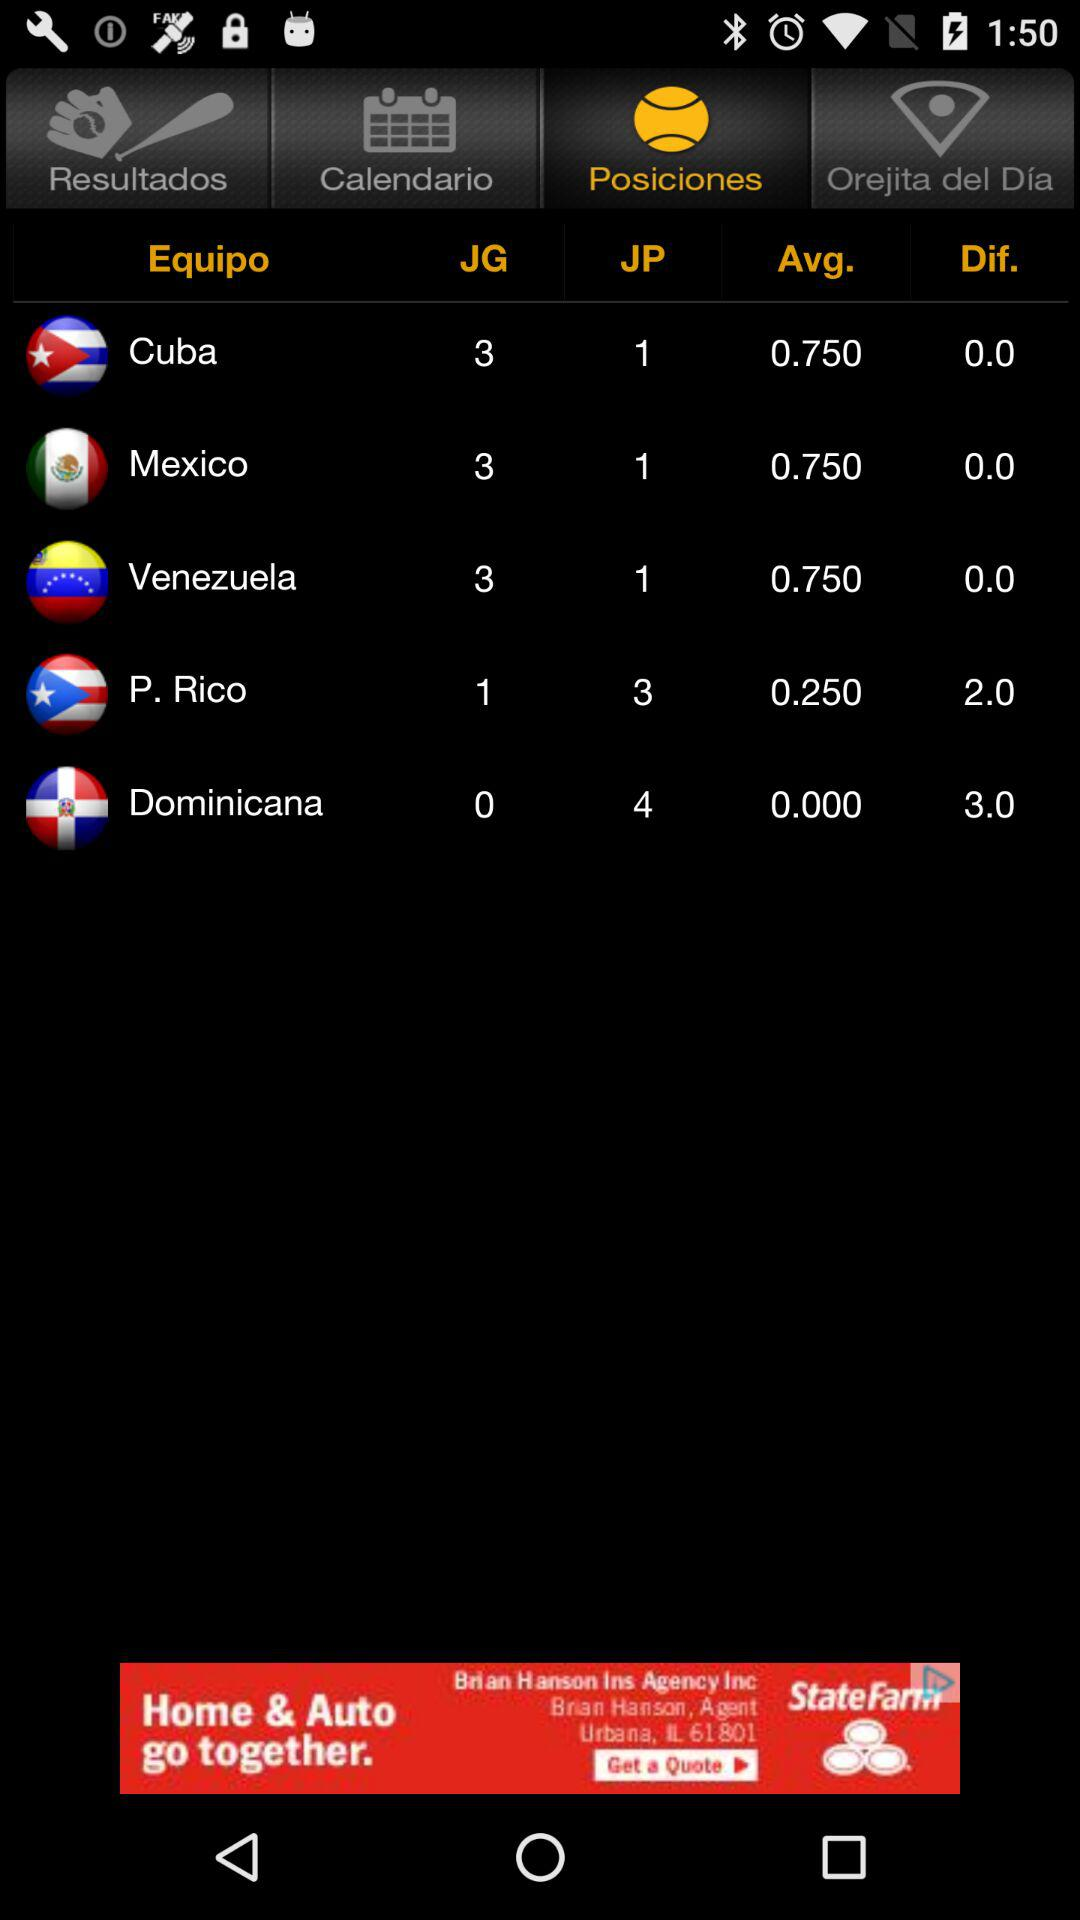How many more wins does Cuba have than Dominican Republic?
Answer the question using a single word or phrase. 3 